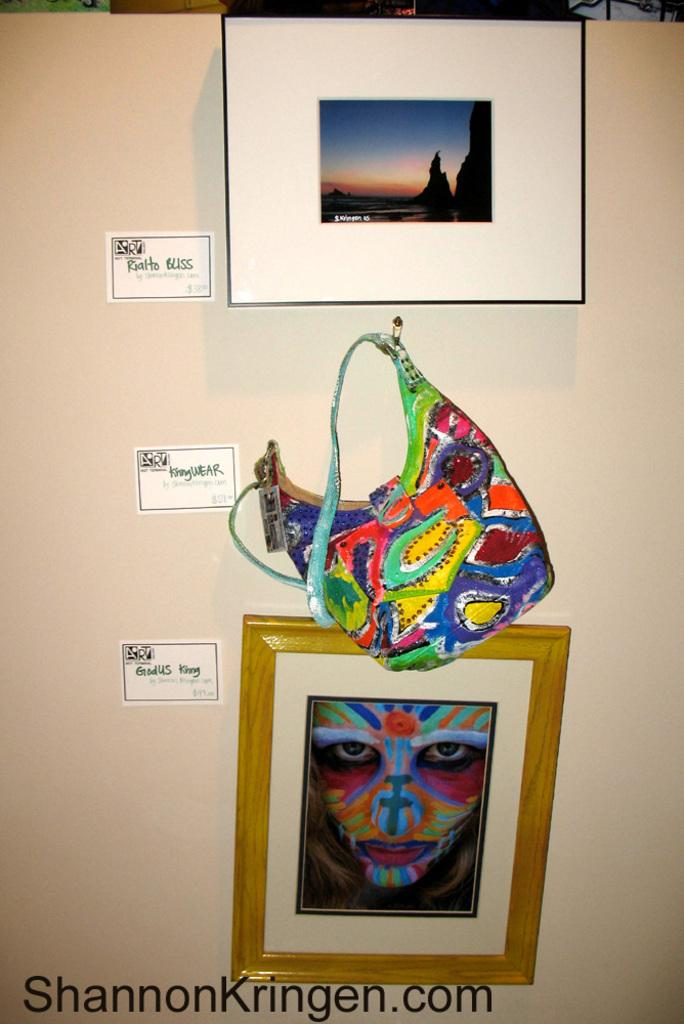What is the main object in the image? There is a whiteboard in the image. What can be seen on the whiteboard? There are stickers, a poster, a bag, and a photo frame on the whiteboard. Can you describe the watermark at the bottom of the image? There is a watermark at the bottom of the image, but its details are not clear from the provided facts. What type of patch is visible on the airplane in the image? There is no airplane present in the image; it features a whiteboard with various items attached to it. Can you tell me the brand of the notebook shown in the image? There is no notebook present in the image; it features a whiteboard with various items attached to it. 